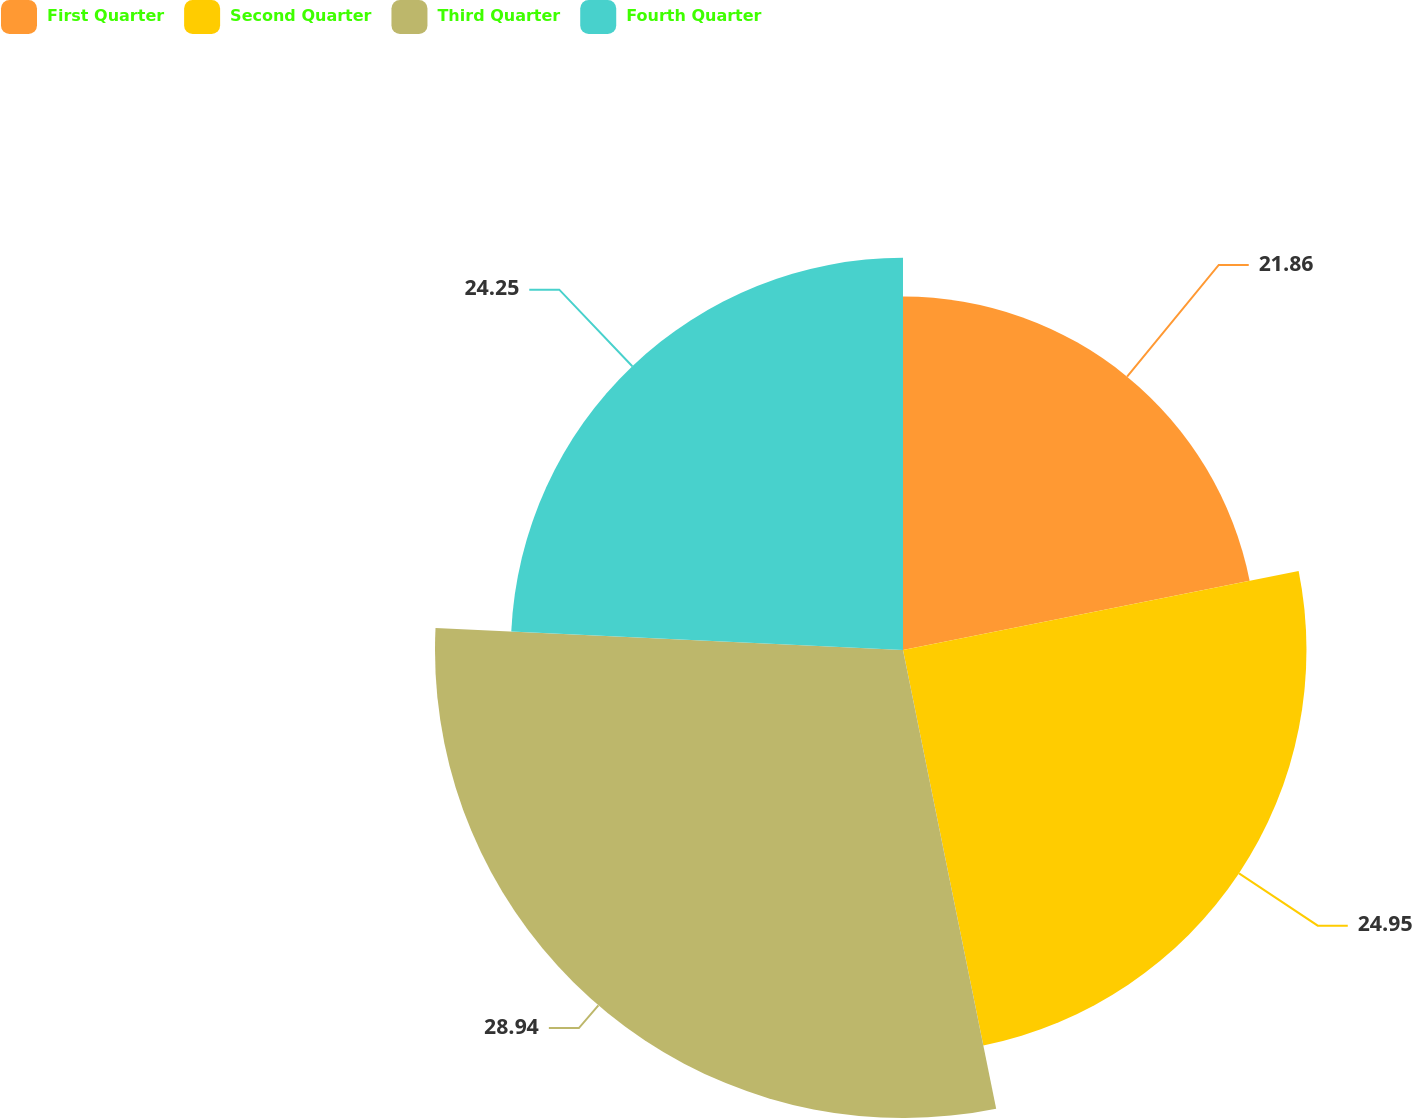Convert chart. <chart><loc_0><loc_0><loc_500><loc_500><pie_chart><fcel>First Quarter<fcel>Second Quarter<fcel>Third Quarter<fcel>Fourth Quarter<nl><fcel>21.86%<fcel>24.95%<fcel>28.94%<fcel>24.25%<nl></chart> 